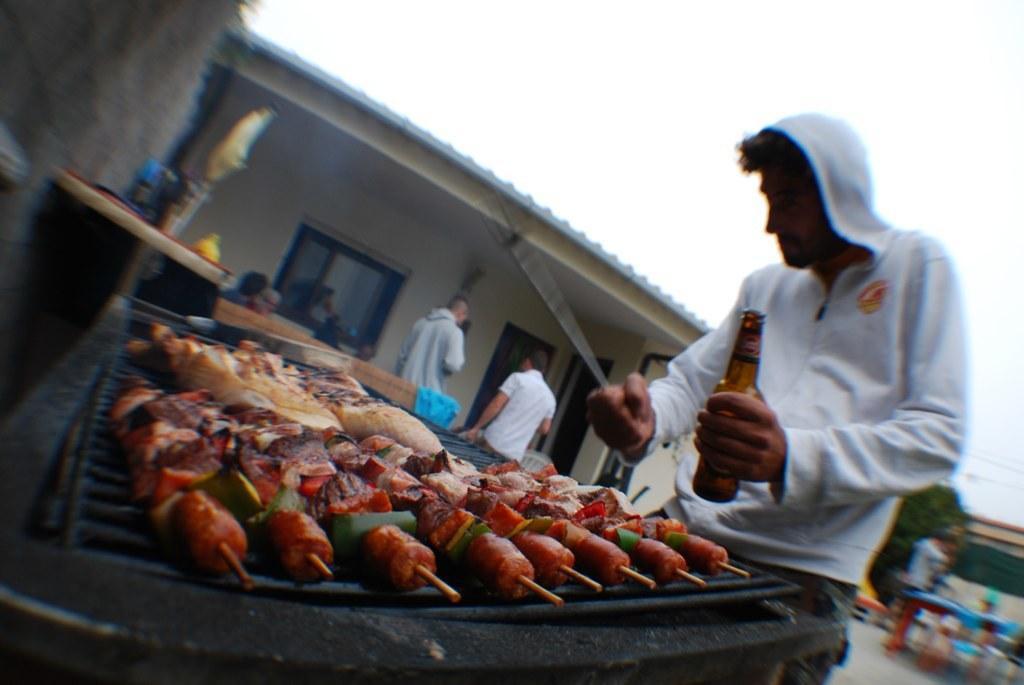In one or two sentences, can you explain what this image depicts? This image is taken outdoors. At the top of the image there is the sky. In the background there is a house. There are two men standing and a few are sitting. In the middle of the image there is a girl with many food items on it. There are two tables. On the right side of the image a man is standing and he is holding a bottle and a stick in his hands. There is a tree. There is a table and a man is standing on the floor. 